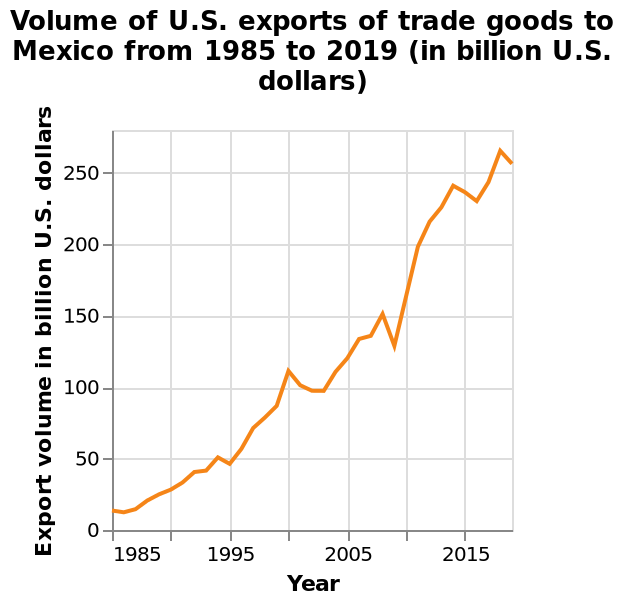<image>
What is the range of the y-axis?  The y-axis ranges from 0 to 250 billion U.S. dollars. What unit is used to measure the export volume? The export volume is measured in billion U.S. dollars. please describe the details of the chart Here a line chart is named Volume of U.S. exports of trade goods to Mexico from 1985 to 2019 (in billion U.S. dollars). Year is shown along a linear scale of range 1985 to 2015 on the x-axis. Along the y-axis, Export volume in billion U.S. dollars is plotted as a linear scale from 0 to 250. please summary the statistics and relations of the chart As time goes on the volume imcreases.  As per the chart you can see the volume is going up drastically. What is the name of the line chart?  The line chart is named "Volume of U.S. exports of trade goods to Mexico". Offer a thorough analysis of the image. There has been a large increase since 1985There was only 4 drops in money over the 20 year period In a 20 year period it has risen to over 250 billion US Dollars. What was the total change in money over the 20 year period? The total change in money over the 20 year period was an increase of over 250 billion US Dollars. 